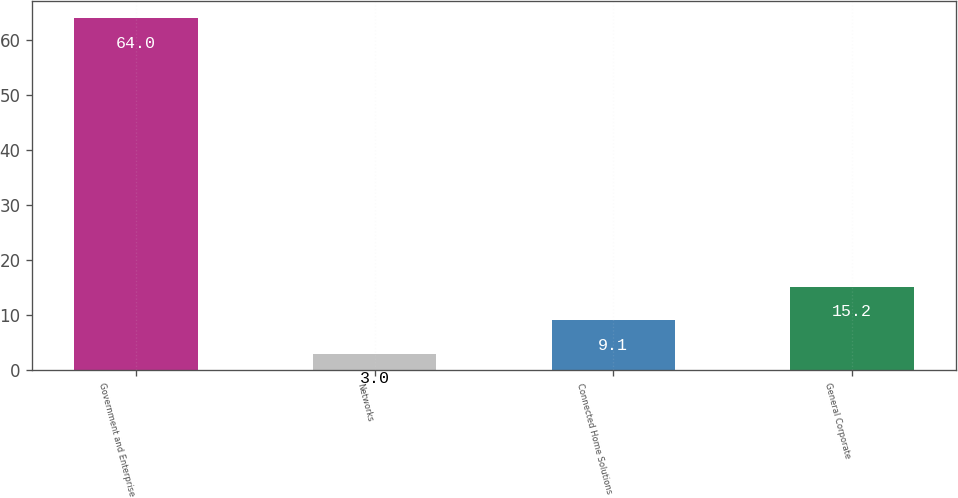<chart> <loc_0><loc_0><loc_500><loc_500><bar_chart><fcel>Government and Enterprise<fcel>Networks<fcel>Connected Home Solutions<fcel>General Corporate<nl><fcel>64<fcel>3<fcel>9.1<fcel>15.2<nl></chart> 